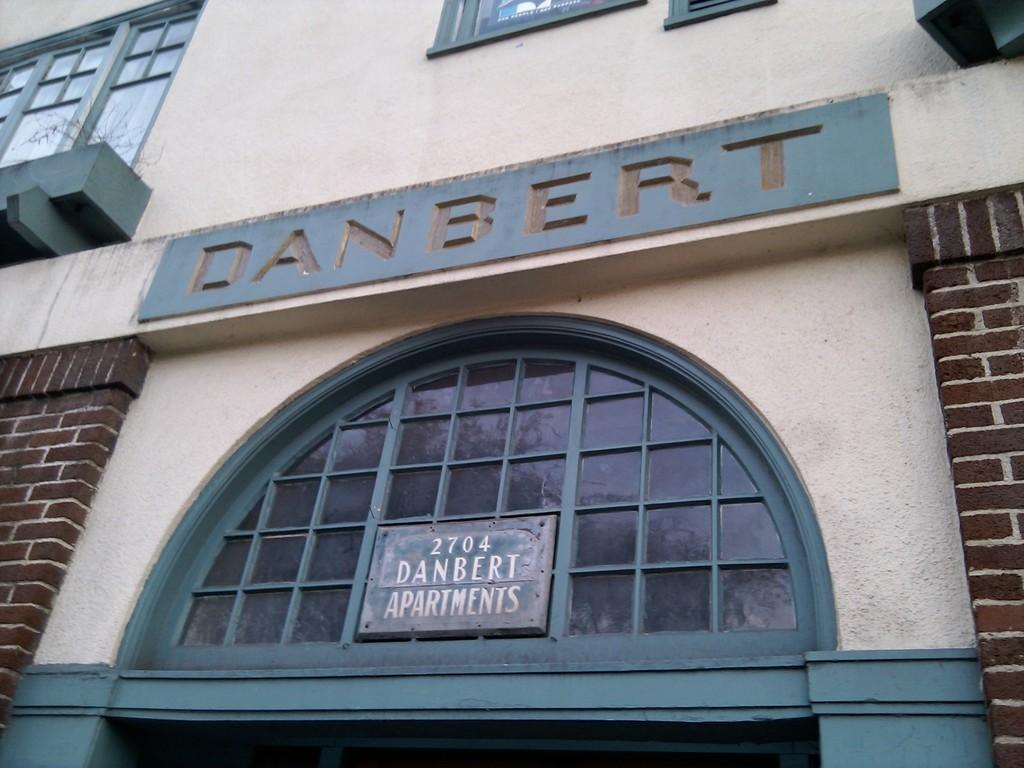Can you describe this image briefly? In this image in front there is a name board with some text on the building. On the left side of the image there is a window. There are some letters on the wall. 